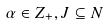Convert formula to latex. <formula><loc_0><loc_0><loc_500><loc_500>\alpha \in Z _ { + } , J \subseteq N</formula> 